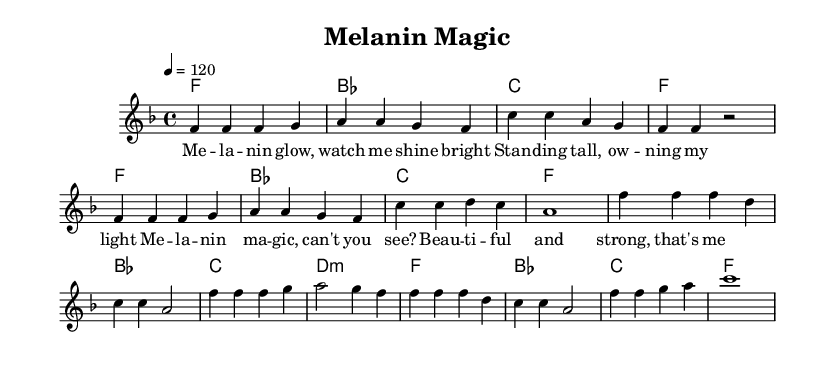What is the key signature of this music? The key signature is F major, which has one flat (B flat). This can be identified at the beginning of the staff where the B flat symbol is placed.
Answer: F major What is the time signature of this music? The time signature is 4/4, indicated by the numbers at the beginning of the score. This means there are four beats in each measure, and the quarter note gets one beat.
Answer: 4/4 What is the tempo marking for this piece? The tempo marking indicates a speed of 120 beats per minute. It is specified using the tempo instruction at the beginning of the score.
Answer: 120 How many measures are in the verse section? The verse section has 8 measures. This can be counted in the melody line, where each group of notes separated by vertical lines indicates a measure.
Answer: 8 What is the total number of chords in the chorus? The chorus features 4 distinct chords, as seen in the section below the melody that lists the harmonic progression. Each chord symbol corresponds to a measure in the melody.
Answer: 4 What is the lyrical theme highlighted in the chorus? The lyrical theme in the chorus emphasizes self-affirmation and beauty, with references to "melanin magic" celebrating identity and strength. This can be inferred from the lyrics provided under the chorus melody.
Answer: Self-affirmation Which note starts the melody of the song? The melody begins with the note F, indicated as the first note in the melody line within the verse section. This is confirmed by observing the notes written in the staff.
Answer: F 